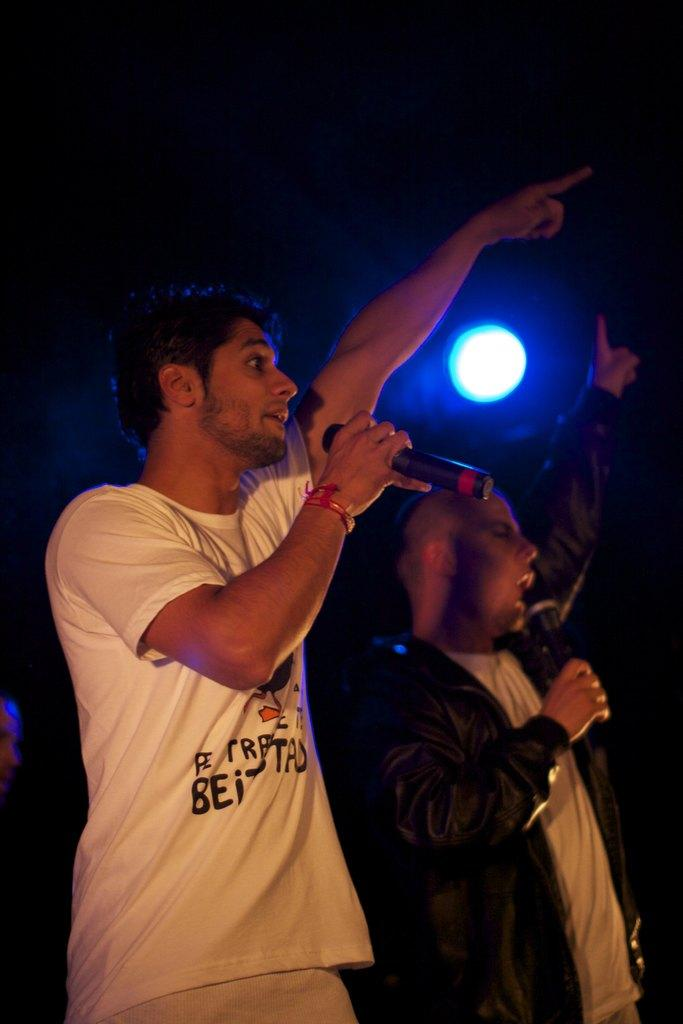How many people are in the image? There are two persons in the image. What are the two persons holding in the image? The two persons are holding microphones. What activity are the two persons engaged in? The two persons are singing. What type of milk is being used by the persons in the image? There is no milk present in the image; the two persons are holding microphones and singing. What type of plant can be seen growing near the persons in the image? There is no plant present in the image; the focus is on the two persons holding microphones and singing. 